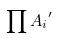Convert formula to latex. <formula><loc_0><loc_0><loc_500><loc_500>\prod { A _ { i } } ^ { \prime }</formula> 